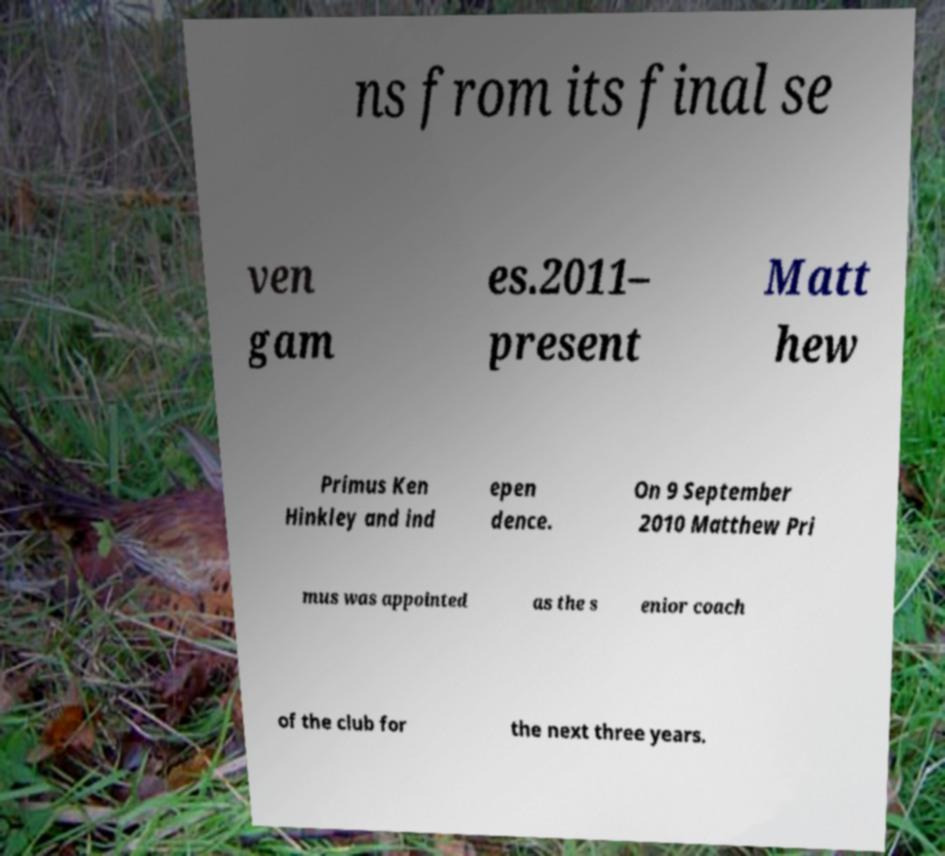Can you read and provide the text displayed in the image?This photo seems to have some interesting text. Can you extract and type it out for me? ns from its final se ven gam es.2011– present Matt hew Primus Ken Hinkley and ind epen dence. On 9 September 2010 Matthew Pri mus was appointed as the s enior coach of the club for the next three years. 